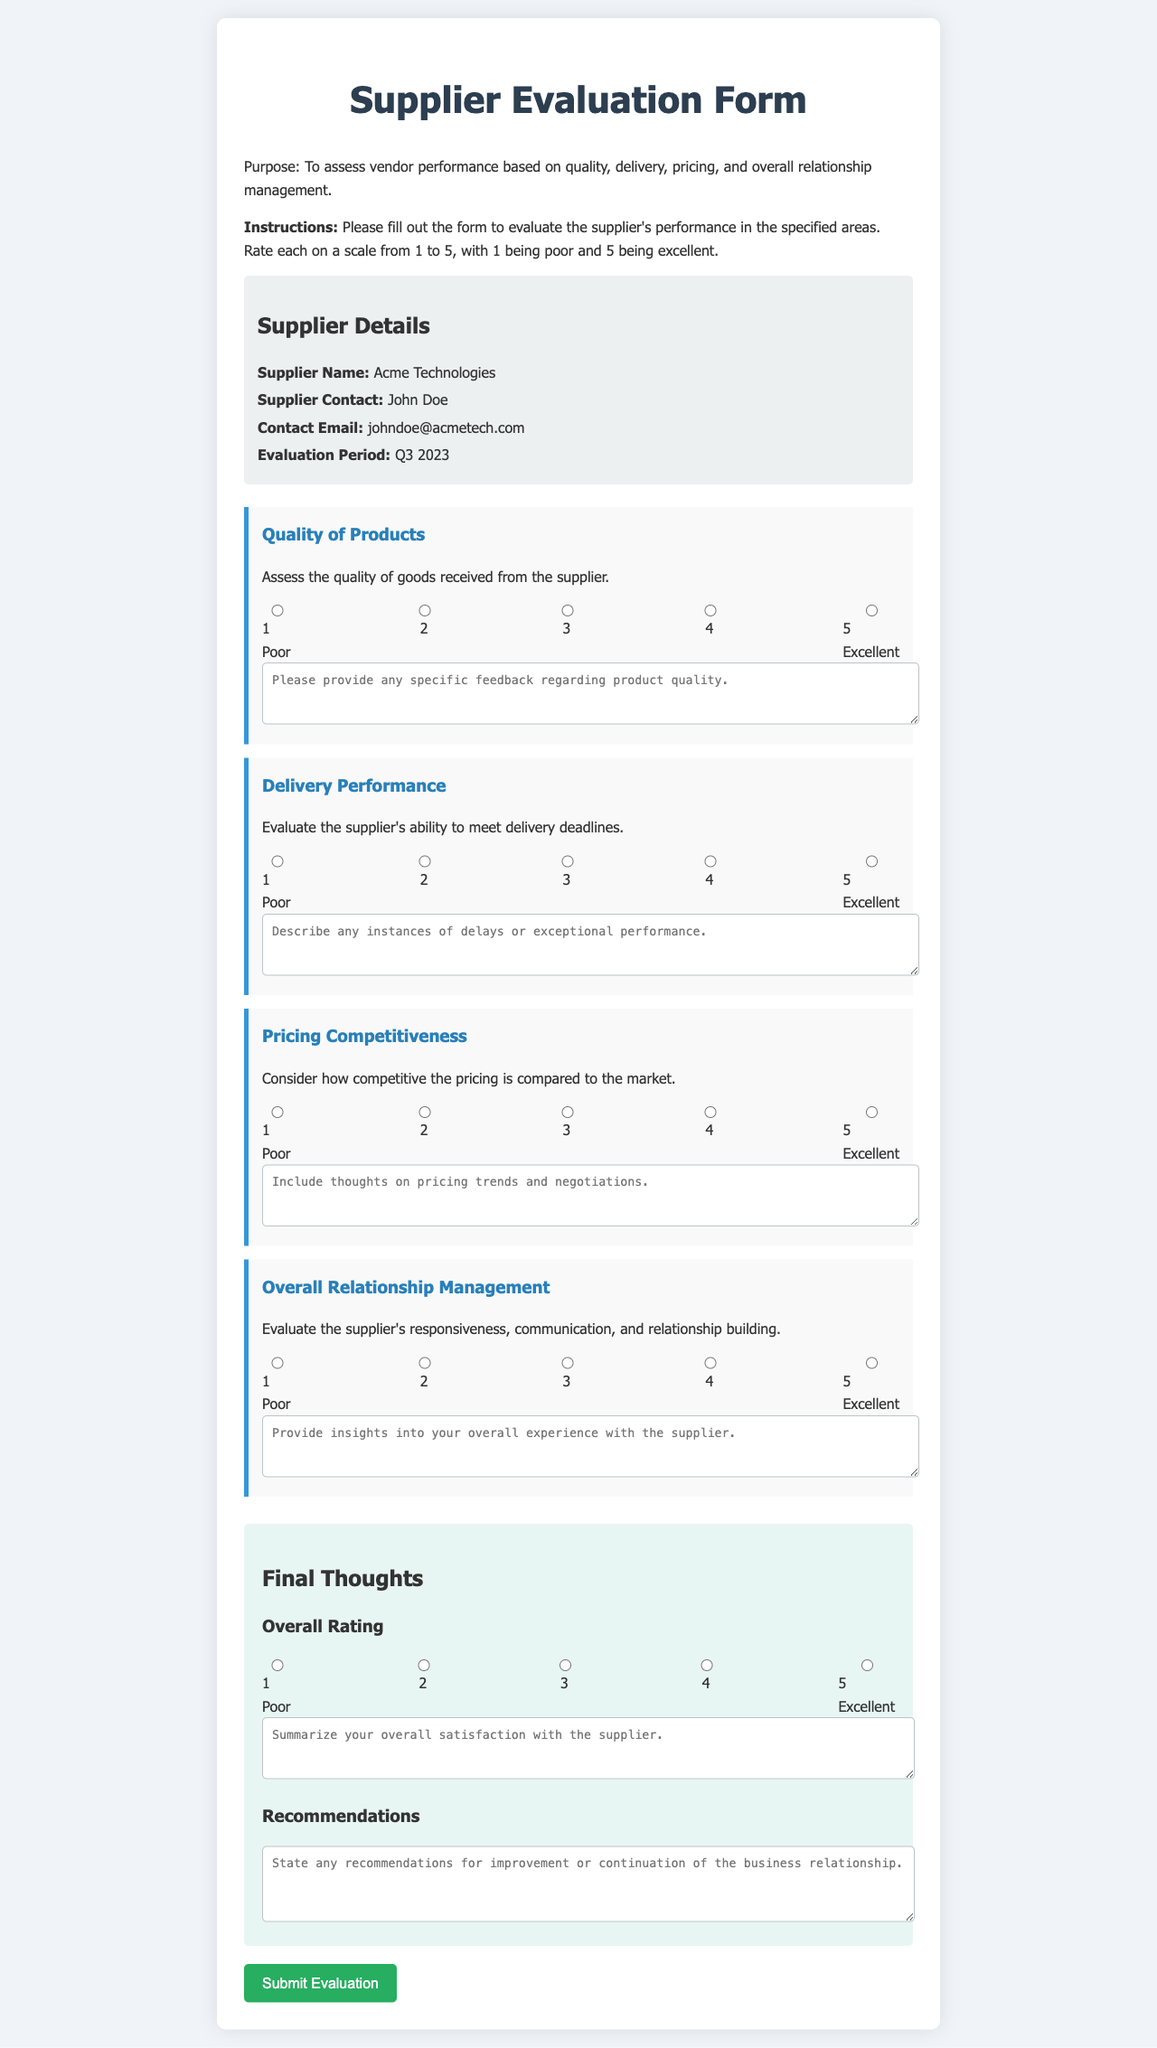What is the supplier's name? The supplier's name is provided in the document under the supplier details section.
Answer: Acme Technologies Who is the supplier contact? The supplier contact person is listed in the supplier details section of the form.
Answer: John Doe What is the evaluation period specified? The evaluation period is stated in the supplier details section of the form, indicating the timeframe being evaluated.
Answer: Q3 2023 What scoring scale is used for evaluation? The scoring scale is defined in the instructions of the form, clarifying how to score the criteria.
Answer: 1 to 5 What is the purpose of the Supplier Evaluation Form? The purpose is mentioned clearly at the beginning of the document, outlining its main goal.
Answer: To assess vendor performance What area is assessed under "Overall Relationship Management"? This area focuses on how suppliers manage responsiveness and communication, illustrating its evaluation criteria.
Answer: Responsiveness, communication, and relationship building What feedback can be provided for product quality? The document allows specific feedback regarding product quality in a designated textarea, highlighting the area for comments.
Answer: Please provide any specific feedback regarding product quality Which section features the overall rating? The overall rating is found in the "Final Thoughts" section of the form where the user summarizes satisfaction.
Answer: Final Thoughts What is the color scheme of the form background? The background color scheme is defined in the CSS style and can be visually observed in the rendered document.
Answer: Light gray and white 